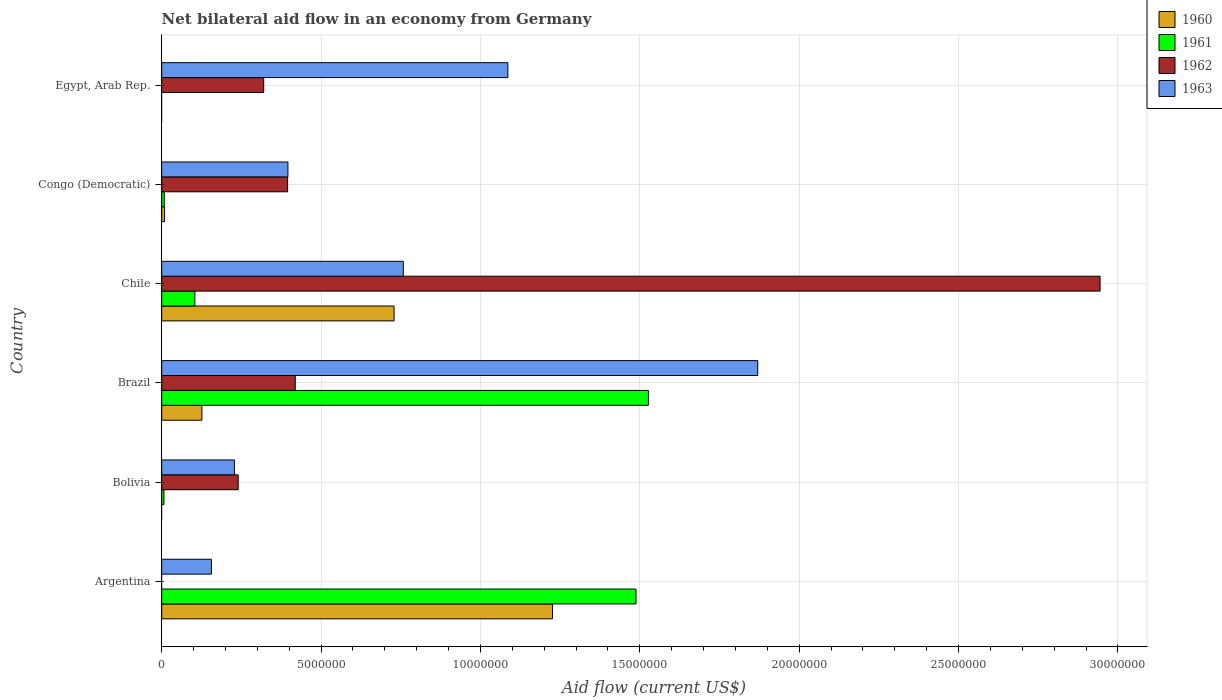How many different coloured bars are there?
Your answer should be very brief. 4. How many groups of bars are there?
Offer a very short reply. 6. Are the number of bars on each tick of the Y-axis equal?
Keep it short and to the point. No. How many bars are there on the 3rd tick from the top?
Give a very brief answer. 4. How many bars are there on the 2nd tick from the bottom?
Your answer should be compact. 3. What is the label of the 3rd group of bars from the top?
Ensure brevity in your answer.  Chile. What is the net bilateral aid flow in 1962 in Egypt, Arab Rep.?
Provide a short and direct response. 3.20e+06. Across all countries, what is the maximum net bilateral aid flow in 1963?
Provide a short and direct response. 1.87e+07. Across all countries, what is the minimum net bilateral aid flow in 1963?
Your response must be concise. 1.56e+06. What is the total net bilateral aid flow in 1963 in the graph?
Provide a short and direct response. 4.49e+07. What is the difference between the net bilateral aid flow in 1961 in Bolivia and that in Chile?
Provide a succinct answer. -9.70e+05. What is the difference between the net bilateral aid flow in 1960 in Congo (Democratic) and the net bilateral aid flow in 1961 in Chile?
Your response must be concise. -9.50e+05. What is the average net bilateral aid flow in 1960 per country?
Offer a terse response. 3.48e+06. What is the difference between the net bilateral aid flow in 1963 and net bilateral aid flow in 1960 in Argentina?
Offer a terse response. -1.07e+07. In how many countries, is the net bilateral aid flow in 1961 greater than 16000000 US$?
Make the answer very short. 0. What is the ratio of the net bilateral aid flow in 1961 in Argentina to that in Bolivia?
Make the answer very short. 212.57. What is the difference between the highest and the second highest net bilateral aid flow in 1961?
Offer a very short reply. 3.90e+05. What is the difference between the highest and the lowest net bilateral aid flow in 1960?
Your response must be concise. 1.23e+07. In how many countries, is the net bilateral aid flow in 1963 greater than the average net bilateral aid flow in 1963 taken over all countries?
Your response must be concise. 3. How many bars are there?
Ensure brevity in your answer.  20. Are all the bars in the graph horizontal?
Provide a short and direct response. Yes. How many countries are there in the graph?
Make the answer very short. 6. What is the difference between two consecutive major ticks on the X-axis?
Offer a terse response. 5.00e+06. Are the values on the major ticks of X-axis written in scientific E-notation?
Ensure brevity in your answer.  No. What is the title of the graph?
Provide a short and direct response. Net bilateral aid flow in an economy from Germany. Does "2013" appear as one of the legend labels in the graph?
Give a very brief answer. No. What is the label or title of the Y-axis?
Your answer should be very brief. Country. What is the Aid flow (current US$) in 1960 in Argentina?
Your answer should be compact. 1.23e+07. What is the Aid flow (current US$) of 1961 in Argentina?
Ensure brevity in your answer.  1.49e+07. What is the Aid flow (current US$) of 1963 in Argentina?
Your answer should be very brief. 1.56e+06. What is the Aid flow (current US$) of 1961 in Bolivia?
Keep it short and to the point. 7.00e+04. What is the Aid flow (current US$) of 1962 in Bolivia?
Provide a succinct answer. 2.40e+06. What is the Aid flow (current US$) of 1963 in Bolivia?
Your answer should be very brief. 2.28e+06. What is the Aid flow (current US$) in 1960 in Brazil?
Your answer should be very brief. 1.26e+06. What is the Aid flow (current US$) in 1961 in Brazil?
Your answer should be compact. 1.53e+07. What is the Aid flow (current US$) in 1962 in Brazil?
Your answer should be compact. 4.19e+06. What is the Aid flow (current US$) in 1963 in Brazil?
Ensure brevity in your answer.  1.87e+07. What is the Aid flow (current US$) of 1960 in Chile?
Offer a very short reply. 7.29e+06. What is the Aid flow (current US$) in 1961 in Chile?
Give a very brief answer. 1.04e+06. What is the Aid flow (current US$) of 1962 in Chile?
Offer a terse response. 2.94e+07. What is the Aid flow (current US$) of 1963 in Chile?
Give a very brief answer. 7.58e+06. What is the Aid flow (current US$) in 1960 in Congo (Democratic)?
Your answer should be very brief. 9.00e+04. What is the Aid flow (current US$) of 1961 in Congo (Democratic)?
Ensure brevity in your answer.  8.00e+04. What is the Aid flow (current US$) of 1962 in Congo (Democratic)?
Provide a succinct answer. 3.95e+06. What is the Aid flow (current US$) in 1963 in Congo (Democratic)?
Provide a succinct answer. 3.96e+06. What is the Aid flow (current US$) of 1960 in Egypt, Arab Rep.?
Your answer should be compact. 0. What is the Aid flow (current US$) in 1962 in Egypt, Arab Rep.?
Ensure brevity in your answer.  3.20e+06. What is the Aid flow (current US$) in 1963 in Egypt, Arab Rep.?
Provide a short and direct response. 1.09e+07. Across all countries, what is the maximum Aid flow (current US$) of 1960?
Your response must be concise. 1.23e+07. Across all countries, what is the maximum Aid flow (current US$) of 1961?
Ensure brevity in your answer.  1.53e+07. Across all countries, what is the maximum Aid flow (current US$) of 1962?
Your answer should be very brief. 2.94e+07. Across all countries, what is the maximum Aid flow (current US$) in 1963?
Give a very brief answer. 1.87e+07. Across all countries, what is the minimum Aid flow (current US$) in 1960?
Ensure brevity in your answer.  0. Across all countries, what is the minimum Aid flow (current US$) of 1962?
Ensure brevity in your answer.  0. Across all countries, what is the minimum Aid flow (current US$) in 1963?
Make the answer very short. 1.56e+06. What is the total Aid flow (current US$) of 1960 in the graph?
Your answer should be very brief. 2.09e+07. What is the total Aid flow (current US$) of 1961 in the graph?
Your answer should be compact. 3.13e+07. What is the total Aid flow (current US$) of 1962 in the graph?
Your answer should be compact. 4.32e+07. What is the total Aid flow (current US$) in 1963 in the graph?
Provide a short and direct response. 4.49e+07. What is the difference between the Aid flow (current US$) in 1961 in Argentina and that in Bolivia?
Make the answer very short. 1.48e+07. What is the difference between the Aid flow (current US$) of 1963 in Argentina and that in Bolivia?
Ensure brevity in your answer.  -7.20e+05. What is the difference between the Aid flow (current US$) in 1960 in Argentina and that in Brazil?
Your answer should be compact. 1.10e+07. What is the difference between the Aid flow (current US$) in 1961 in Argentina and that in Brazil?
Your answer should be very brief. -3.90e+05. What is the difference between the Aid flow (current US$) of 1963 in Argentina and that in Brazil?
Offer a very short reply. -1.71e+07. What is the difference between the Aid flow (current US$) in 1960 in Argentina and that in Chile?
Keep it short and to the point. 4.97e+06. What is the difference between the Aid flow (current US$) of 1961 in Argentina and that in Chile?
Offer a terse response. 1.38e+07. What is the difference between the Aid flow (current US$) of 1963 in Argentina and that in Chile?
Your answer should be very brief. -6.02e+06. What is the difference between the Aid flow (current US$) in 1960 in Argentina and that in Congo (Democratic)?
Your answer should be very brief. 1.22e+07. What is the difference between the Aid flow (current US$) in 1961 in Argentina and that in Congo (Democratic)?
Make the answer very short. 1.48e+07. What is the difference between the Aid flow (current US$) of 1963 in Argentina and that in Congo (Democratic)?
Ensure brevity in your answer.  -2.40e+06. What is the difference between the Aid flow (current US$) in 1963 in Argentina and that in Egypt, Arab Rep.?
Ensure brevity in your answer.  -9.30e+06. What is the difference between the Aid flow (current US$) of 1961 in Bolivia and that in Brazil?
Your answer should be very brief. -1.52e+07. What is the difference between the Aid flow (current US$) of 1962 in Bolivia and that in Brazil?
Your answer should be very brief. -1.79e+06. What is the difference between the Aid flow (current US$) in 1963 in Bolivia and that in Brazil?
Ensure brevity in your answer.  -1.64e+07. What is the difference between the Aid flow (current US$) in 1961 in Bolivia and that in Chile?
Make the answer very short. -9.70e+05. What is the difference between the Aid flow (current US$) of 1962 in Bolivia and that in Chile?
Your response must be concise. -2.70e+07. What is the difference between the Aid flow (current US$) in 1963 in Bolivia and that in Chile?
Keep it short and to the point. -5.30e+06. What is the difference between the Aid flow (current US$) of 1962 in Bolivia and that in Congo (Democratic)?
Your answer should be very brief. -1.55e+06. What is the difference between the Aid flow (current US$) of 1963 in Bolivia and that in Congo (Democratic)?
Offer a terse response. -1.68e+06. What is the difference between the Aid flow (current US$) of 1962 in Bolivia and that in Egypt, Arab Rep.?
Ensure brevity in your answer.  -8.00e+05. What is the difference between the Aid flow (current US$) of 1963 in Bolivia and that in Egypt, Arab Rep.?
Offer a very short reply. -8.58e+06. What is the difference between the Aid flow (current US$) in 1960 in Brazil and that in Chile?
Ensure brevity in your answer.  -6.03e+06. What is the difference between the Aid flow (current US$) of 1961 in Brazil and that in Chile?
Ensure brevity in your answer.  1.42e+07. What is the difference between the Aid flow (current US$) of 1962 in Brazil and that in Chile?
Give a very brief answer. -2.52e+07. What is the difference between the Aid flow (current US$) of 1963 in Brazil and that in Chile?
Your response must be concise. 1.11e+07. What is the difference between the Aid flow (current US$) of 1960 in Brazil and that in Congo (Democratic)?
Give a very brief answer. 1.17e+06. What is the difference between the Aid flow (current US$) in 1961 in Brazil and that in Congo (Democratic)?
Keep it short and to the point. 1.52e+07. What is the difference between the Aid flow (current US$) of 1962 in Brazil and that in Congo (Democratic)?
Offer a terse response. 2.40e+05. What is the difference between the Aid flow (current US$) of 1963 in Brazil and that in Congo (Democratic)?
Make the answer very short. 1.47e+07. What is the difference between the Aid flow (current US$) in 1962 in Brazil and that in Egypt, Arab Rep.?
Provide a succinct answer. 9.90e+05. What is the difference between the Aid flow (current US$) of 1963 in Brazil and that in Egypt, Arab Rep.?
Keep it short and to the point. 7.84e+06. What is the difference between the Aid flow (current US$) of 1960 in Chile and that in Congo (Democratic)?
Your response must be concise. 7.20e+06. What is the difference between the Aid flow (current US$) in 1961 in Chile and that in Congo (Democratic)?
Your response must be concise. 9.60e+05. What is the difference between the Aid flow (current US$) in 1962 in Chile and that in Congo (Democratic)?
Your answer should be very brief. 2.55e+07. What is the difference between the Aid flow (current US$) of 1963 in Chile and that in Congo (Democratic)?
Make the answer very short. 3.62e+06. What is the difference between the Aid flow (current US$) in 1962 in Chile and that in Egypt, Arab Rep.?
Offer a very short reply. 2.62e+07. What is the difference between the Aid flow (current US$) in 1963 in Chile and that in Egypt, Arab Rep.?
Offer a terse response. -3.28e+06. What is the difference between the Aid flow (current US$) of 1962 in Congo (Democratic) and that in Egypt, Arab Rep.?
Your response must be concise. 7.50e+05. What is the difference between the Aid flow (current US$) in 1963 in Congo (Democratic) and that in Egypt, Arab Rep.?
Provide a succinct answer. -6.90e+06. What is the difference between the Aid flow (current US$) in 1960 in Argentina and the Aid flow (current US$) in 1961 in Bolivia?
Give a very brief answer. 1.22e+07. What is the difference between the Aid flow (current US$) of 1960 in Argentina and the Aid flow (current US$) of 1962 in Bolivia?
Your answer should be very brief. 9.86e+06. What is the difference between the Aid flow (current US$) in 1960 in Argentina and the Aid flow (current US$) in 1963 in Bolivia?
Ensure brevity in your answer.  9.98e+06. What is the difference between the Aid flow (current US$) in 1961 in Argentina and the Aid flow (current US$) in 1962 in Bolivia?
Give a very brief answer. 1.25e+07. What is the difference between the Aid flow (current US$) of 1961 in Argentina and the Aid flow (current US$) of 1963 in Bolivia?
Make the answer very short. 1.26e+07. What is the difference between the Aid flow (current US$) in 1960 in Argentina and the Aid flow (current US$) in 1961 in Brazil?
Provide a short and direct response. -3.01e+06. What is the difference between the Aid flow (current US$) of 1960 in Argentina and the Aid flow (current US$) of 1962 in Brazil?
Ensure brevity in your answer.  8.07e+06. What is the difference between the Aid flow (current US$) of 1960 in Argentina and the Aid flow (current US$) of 1963 in Brazil?
Ensure brevity in your answer.  -6.44e+06. What is the difference between the Aid flow (current US$) of 1961 in Argentina and the Aid flow (current US$) of 1962 in Brazil?
Your answer should be compact. 1.07e+07. What is the difference between the Aid flow (current US$) of 1961 in Argentina and the Aid flow (current US$) of 1963 in Brazil?
Your answer should be compact. -3.82e+06. What is the difference between the Aid flow (current US$) in 1960 in Argentina and the Aid flow (current US$) in 1961 in Chile?
Your answer should be compact. 1.12e+07. What is the difference between the Aid flow (current US$) in 1960 in Argentina and the Aid flow (current US$) in 1962 in Chile?
Provide a short and direct response. -1.72e+07. What is the difference between the Aid flow (current US$) of 1960 in Argentina and the Aid flow (current US$) of 1963 in Chile?
Your answer should be very brief. 4.68e+06. What is the difference between the Aid flow (current US$) of 1961 in Argentina and the Aid flow (current US$) of 1962 in Chile?
Your response must be concise. -1.46e+07. What is the difference between the Aid flow (current US$) in 1961 in Argentina and the Aid flow (current US$) in 1963 in Chile?
Your answer should be very brief. 7.30e+06. What is the difference between the Aid flow (current US$) of 1960 in Argentina and the Aid flow (current US$) of 1961 in Congo (Democratic)?
Offer a terse response. 1.22e+07. What is the difference between the Aid flow (current US$) of 1960 in Argentina and the Aid flow (current US$) of 1962 in Congo (Democratic)?
Your response must be concise. 8.31e+06. What is the difference between the Aid flow (current US$) in 1960 in Argentina and the Aid flow (current US$) in 1963 in Congo (Democratic)?
Your answer should be compact. 8.30e+06. What is the difference between the Aid flow (current US$) of 1961 in Argentina and the Aid flow (current US$) of 1962 in Congo (Democratic)?
Provide a short and direct response. 1.09e+07. What is the difference between the Aid flow (current US$) in 1961 in Argentina and the Aid flow (current US$) in 1963 in Congo (Democratic)?
Offer a terse response. 1.09e+07. What is the difference between the Aid flow (current US$) in 1960 in Argentina and the Aid flow (current US$) in 1962 in Egypt, Arab Rep.?
Provide a succinct answer. 9.06e+06. What is the difference between the Aid flow (current US$) of 1960 in Argentina and the Aid flow (current US$) of 1963 in Egypt, Arab Rep.?
Your response must be concise. 1.40e+06. What is the difference between the Aid flow (current US$) in 1961 in Argentina and the Aid flow (current US$) in 1962 in Egypt, Arab Rep.?
Make the answer very short. 1.17e+07. What is the difference between the Aid flow (current US$) in 1961 in Argentina and the Aid flow (current US$) in 1963 in Egypt, Arab Rep.?
Make the answer very short. 4.02e+06. What is the difference between the Aid flow (current US$) in 1961 in Bolivia and the Aid flow (current US$) in 1962 in Brazil?
Your response must be concise. -4.12e+06. What is the difference between the Aid flow (current US$) of 1961 in Bolivia and the Aid flow (current US$) of 1963 in Brazil?
Provide a short and direct response. -1.86e+07. What is the difference between the Aid flow (current US$) of 1962 in Bolivia and the Aid flow (current US$) of 1963 in Brazil?
Your answer should be compact. -1.63e+07. What is the difference between the Aid flow (current US$) in 1961 in Bolivia and the Aid flow (current US$) in 1962 in Chile?
Provide a short and direct response. -2.94e+07. What is the difference between the Aid flow (current US$) of 1961 in Bolivia and the Aid flow (current US$) of 1963 in Chile?
Your answer should be very brief. -7.51e+06. What is the difference between the Aid flow (current US$) in 1962 in Bolivia and the Aid flow (current US$) in 1963 in Chile?
Provide a short and direct response. -5.18e+06. What is the difference between the Aid flow (current US$) in 1961 in Bolivia and the Aid flow (current US$) in 1962 in Congo (Democratic)?
Offer a terse response. -3.88e+06. What is the difference between the Aid flow (current US$) of 1961 in Bolivia and the Aid flow (current US$) of 1963 in Congo (Democratic)?
Your answer should be compact. -3.89e+06. What is the difference between the Aid flow (current US$) of 1962 in Bolivia and the Aid flow (current US$) of 1963 in Congo (Democratic)?
Offer a terse response. -1.56e+06. What is the difference between the Aid flow (current US$) in 1961 in Bolivia and the Aid flow (current US$) in 1962 in Egypt, Arab Rep.?
Provide a succinct answer. -3.13e+06. What is the difference between the Aid flow (current US$) of 1961 in Bolivia and the Aid flow (current US$) of 1963 in Egypt, Arab Rep.?
Make the answer very short. -1.08e+07. What is the difference between the Aid flow (current US$) of 1962 in Bolivia and the Aid flow (current US$) of 1963 in Egypt, Arab Rep.?
Offer a terse response. -8.46e+06. What is the difference between the Aid flow (current US$) of 1960 in Brazil and the Aid flow (current US$) of 1961 in Chile?
Keep it short and to the point. 2.20e+05. What is the difference between the Aid flow (current US$) of 1960 in Brazil and the Aid flow (current US$) of 1962 in Chile?
Your answer should be compact. -2.82e+07. What is the difference between the Aid flow (current US$) of 1960 in Brazil and the Aid flow (current US$) of 1963 in Chile?
Provide a short and direct response. -6.32e+06. What is the difference between the Aid flow (current US$) of 1961 in Brazil and the Aid flow (current US$) of 1962 in Chile?
Provide a short and direct response. -1.42e+07. What is the difference between the Aid flow (current US$) in 1961 in Brazil and the Aid flow (current US$) in 1963 in Chile?
Ensure brevity in your answer.  7.69e+06. What is the difference between the Aid flow (current US$) of 1962 in Brazil and the Aid flow (current US$) of 1963 in Chile?
Your response must be concise. -3.39e+06. What is the difference between the Aid flow (current US$) of 1960 in Brazil and the Aid flow (current US$) of 1961 in Congo (Democratic)?
Provide a short and direct response. 1.18e+06. What is the difference between the Aid flow (current US$) in 1960 in Brazil and the Aid flow (current US$) in 1962 in Congo (Democratic)?
Your answer should be very brief. -2.69e+06. What is the difference between the Aid flow (current US$) in 1960 in Brazil and the Aid flow (current US$) in 1963 in Congo (Democratic)?
Give a very brief answer. -2.70e+06. What is the difference between the Aid flow (current US$) of 1961 in Brazil and the Aid flow (current US$) of 1962 in Congo (Democratic)?
Keep it short and to the point. 1.13e+07. What is the difference between the Aid flow (current US$) of 1961 in Brazil and the Aid flow (current US$) of 1963 in Congo (Democratic)?
Your response must be concise. 1.13e+07. What is the difference between the Aid flow (current US$) of 1962 in Brazil and the Aid flow (current US$) of 1963 in Congo (Democratic)?
Provide a short and direct response. 2.30e+05. What is the difference between the Aid flow (current US$) of 1960 in Brazil and the Aid flow (current US$) of 1962 in Egypt, Arab Rep.?
Keep it short and to the point. -1.94e+06. What is the difference between the Aid flow (current US$) in 1960 in Brazil and the Aid flow (current US$) in 1963 in Egypt, Arab Rep.?
Offer a very short reply. -9.60e+06. What is the difference between the Aid flow (current US$) of 1961 in Brazil and the Aid flow (current US$) of 1962 in Egypt, Arab Rep.?
Ensure brevity in your answer.  1.21e+07. What is the difference between the Aid flow (current US$) in 1961 in Brazil and the Aid flow (current US$) in 1963 in Egypt, Arab Rep.?
Your answer should be very brief. 4.41e+06. What is the difference between the Aid flow (current US$) of 1962 in Brazil and the Aid flow (current US$) of 1963 in Egypt, Arab Rep.?
Your response must be concise. -6.67e+06. What is the difference between the Aid flow (current US$) of 1960 in Chile and the Aid flow (current US$) of 1961 in Congo (Democratic)?
Offer a terse response. 7.21e+06. What is the difference between the Aid flow (current US$) in 1960 in Chile and the Aid flow (current US$) in 1962 in Congo (Democratic)?
Give a very brief answer. 3.34e+06. What is the difference between the Aid flow (current US$) of 1960 in Chile and the Aid flow (current US$) of 1963 in Congo (Democratic)?
Your answer should be compact. 3.33e+06. What is the difference between the Aid flow (current US$) of 1961 in Chile and the Aid flow (current US$) of 1962 in Congo (Democratic)?
Provide a short and direct response. -2.91e+06. What is the difference between the Aid flow (current US$) of 1961 in Chile and the Aid flow (current US$) of 1963 in Congo (Democratic)?
Your response must be concise. -2.92e+06. What is the difference between the Aid flow (current US$) in 1962 in Chile and the Aid flow (current US$) in 1963 in Congo (Democratic)?
Your response must be concise. 2.55e+07. What is the difference between the Aid flow (current US$) in 1960 in Chile and the Aid flow (current US$) in 1962 in Egypt, Arab Rep.?
Keep it short and to the point. 4.09e+06. What is the difference between the Aid flow (current US$) of 1960 in Chile and the Aid flow (current US$) of 1963 in Egypt, Arab Rep.?
Provide a short and direct response. -3.57e+06. What is the difference between the Aid flow (current US$) in 1961 in Chile and the Aid flow (current US$) in 1962 in Egypt, Arab Rep.?
Ensure brevity in your answer.  -2.16e+06. What is the difference between the Aid flow (current US$) in 1961 in Chile and the Aid flow (current US$) in 1963 in Egypt, Arab Rep.?
Your response must be concise. -9.82e+06. What is the difference between the Aid flow (current US$) in 1962 in Chile and the Aid flow (current US$) in 1963 in Egypt, Arab Rep.?
Offer a very short reply. 1.86e+07. What is the difference between the Aid flow (current US$) of 1960 in Congo (Democratic) and the Aid flow (current US$) of 1962 in Egypt, Arab Rep.?
Offer a very short reply. -3.11e+06. What is the difference between the Aid flow (current US$) in 1960 in Congo (Democratic) and the Aid flow (current US$) in 1963 in Egypt, Arab Rep.?
Ensure brevity in your answer.  -1.08e+07. What is the difference between the Aid flow (current US$) of 1961 in Congo (Democratic) and the Aid flow (current US$) of 1962 in Egypt, Arab Rep.?
Give a very brief answer. -3.12e+06. What is the difference between the Aid flow (current US$) in 1961 in Congo (Democratic) and the Aid flow (current US$) in 1963 in Egypt, Arab Rep.?
Ensure brevity in your answer.  -1.08e+07. What is the difference between the Aid flow (current US$) of 1962 in Congo (Democratic) and the Aid flow (current US$) of 1963 in Egypt, Arab Rep.?
Ensure brevity in your answer.  -6.91e+06. What is the average Aid flow (current US$) of 1960 per country?
Your answer should be compact. 3.48e+06. What is the average Aid flow (current US$) of 1961 per country?
Make the answer very short. 5.22e+06. What is the average Aid flow (current US$) in 1962 per country?
Your response must be concise. 7.20e+06. What is the average Aid flow (current US$) of 1963 per country?
Your response must be concise. 7.49e+06. What is the difference between the Aid flow (current US$) of 1960 and Aid flow (current US$) of 1961 in Argentina?
Provide a succinct answer. -2.62e+06. What is the difference between the Aid flow (current US$) in 1960 and Aid flow (current US$) in 1963 in Argentina?
Give a very brief answer. 1.07e+07. What is the difference between the Aid flow (current US$) of 1961 and Aid flow (current US$) of 1963 in Argentina?
Your answer should be very brief. 1.33e+07. What is the difference between the Aid flow (current US$) of 1961 and Aid flow (current US$) of 1962 in Bolivia?
Offer a very short reply. -2.33e+06. What is the difference between the Aid flow (current US$) in 1961 and Aid flow (current US$) in 1963 in Bolivia?
Offer a very short reply. -2.21e+06. What is the difference between the Aid flow (current US$) in 1960 and Aid flow (current US$) in 1961 in Brazil?
Offer a terse response. -1.40e+07. What is the difference between the Aid flow (current US$) of 1960 and Aid flow (current US$) of 1962 in Brazil?
Keep it short and to the point. -2.93e+06. What is the difference between the Aid flow (current US$) of 1960 and Aid flow (current US$) of 1963 in Brazil?
Offer a terse response. -1.74e+07. What is the difference between the Aid flow (current US$) in 1961 and Aid flow (current US$) in 1962 in Brazil?
Your response must be concise. 1.11e+07. What is the difference between the Aid flow (current US$) of 1961 and Aid flow (current US$) of 1963 in Brazil?
Your answer should be very brief. -3.43e+06. What is the difference between the Aid flow (current US$) of 1962 and Aid flow (current US$) of 1963 in Brazil?
Your answer should be compact. -1.45e+07. What is the difference between the Aid flow (current US$) of 1960 and Aid flow (current US$) of 1961 in Chile?
Provide a short and direct response. 6.25e+06. What is the difference between the Aid flow (current US$) in 1960 and Aid flow (current US$) in 1962 in Chile?
Your answer should be compact. -2.22e+07. What is the difference between the Aid flow (current US$) in 1961 and Aid flow (current US$) in 1962 in Chile?
Your answer should be very brief. -2.84e+07. What is the difference between the Aid flow (current US$) in 1961 and Aid flow (current US$) in 1963 in Chile?
Your answer should be compact. -6.54e+06. What is the difference between the Aid flow (current US$) in 1962 and Aid flow (current US$) in 1963 in Chile?
Make the answer very short. 2.19e+07. What is the difference between the Aid flow (current US$) in 1960 and Aid flow (current US$) in 1961 in Congo (Democratic)?
Provide a short and direct response. 10000. What is the difference between the Aid flow (current US$) of 1960 and Aid flow (current US$) of 1962 in Congo (Democratic)?
Provide a short and direct response. -3.86e+06. What is the difference between the Aid flow (current US$) in 1960 and Aid flow (current US$) in 1963 in Congo (Democratic)?
Your response must be concise. -3.87e+06. What is the difference between the Aid flow (current US$) of 1961 and Aid flow (current US$) of 1962 in Congo (Democratic)?
Keep it short and to the point. -3.87e+06. What is the difference between the Aid flow (current US$) of 1961 and Aid flow (current US$) of 1963 in Congo (Democratic)?
Offer a very short reply. -3.88e+06. What is the difference between the Aid flow (current US$) in 1962 and Aid flow (current US$) in 1963 in Congo (Democratic)?
Keep it short and to the point. -10000. What is the difference between the Aid flow (current US$) in 1962 and Aid flow (current US$) in 1963 in Egypt, Arab Rep.?
Give a very brief answer. -7.66e+06. What is the ratio of the Aid flow (current US$) in 1961 in Argentina to that in Bolivia?
Provide a short and direct response. 212.57. What is the ratio of the Aid flow (current US$) of 1963 in Argentina to that in Bolivia?
Provide a short and direct response. 0.68. What is the ratio of the Aid flow (current US$) of 1960 in Argentina to that in Brazil?
Offer a very short reply. 9.73. What is the ratio of the Aid flow (current US$) in 1961 in Argentina to that in Brazil?
Provide a succinct answer. 0.97. What is the ratio of the Aid flow (current US$) in 1963 in Argentina to that in Brazil?
Your answer should be very brief. 0.08. What is the ratio of the Aid flow (current US$) in 1960 in Argentina to that in Chile?
Offer a very short reply. 1.68. What is the ratio of the Aid flow (current US$) in 1961 in Argentina to that in Chile?
Ensure brevity in your answer.  14.31. What is the ratio of the Aid flow (current US$) of 1963 in Argentina to that in Chile?
Give a very brief answer. 0.21. What is the ratio of the Aid flow (current US$) of 1960 in Argentina to that in Congo (Democratic)?
Keep it short and to the point. 136.22. What is the ratio of the Aid flow (current US$) of 1961 in Argentina to that in Congo (Democratic)?
Offer a very short reply. 186. What is the ratio of the Aid flow (current US$) in 1963 in Argentina to that in Congo (Democratic)?
Your answer should be compact. 0.39. What is the ratio of the Aid flow (current US$) of 1963 in Argentina to that in Egypt, Arab Rep.?
Provide a succinct answer. 0.14. What is the ratio of the Aid flow (current US$) of 1961 in Bolivia to that in Brazil?
Your answer should be compact. 0. What is the ratio of the Aid flow (current US$) in 1962 in Bolivia to that in Brazil?
Make the answer very short. 0.57. What is the ratio of the Aid flow (current US$) of 1963 in Bolivia to that in Brazil?
Provide a short and direct response. 0.12. What is the ratio of the Aid flow (current US$) of 1961 in Bolivia to that in Chile?
Your answer should be compact. 0.07. What is the ratio of the Aid flow (current US$) of 1962 in Bolivia to that in Chile?
Provide a short and direct response. 0.08. What is the ratio of the Aid flow (current US$) in 1963 in Bolivia to that in Chile?
Provide a succinct answer. 0.3. What is the ratio of the Aid flow (current US$) of 1961 in Bolivia to that in Congo (Democratic)?
Give a very brief answer. 0.88. What is the ratio of the Aid flow (current US$) in 1962 in Bolivia to that in Congo (Democratic)?
Ensure brevity in your answer.  0.61. What is the ratio of the Aid flow (current US$) in 1963 in Bolivia to that in Congo (Democratic)?
Offer a terse response. 0.58. What is the ratio of the Aid flow (current US$) in 1962 in Bolivia to that in Egypt, Arab Rep.?
Offer a terse response. 0.75. What is the ratio of the Aid flow (current US$) of 1963 in Bolivia to that in Egypt, Arab Rep.?
Give a very brief answer. 0.21. What is the ratio of the Aid flow (current US$) in 1960 in Brazil to that in Chile?
Make the answer very short. 0.17. What is the ratio of the Aid flow (current US$) in 1961 in Brazil to that in Chile?
Keep it short and to the point. 14.68. What is the ratio of the Aid flow (current US$) of 1962 in Brazil to that in Chile?
Provide a short and direct response. 0.14. What is the ratio of the Aid flow (current US$) in 1963 in Brazil to that in Chile?
Ensure brevity in your answer.  2.47. What is the ratio of the Aid flow (current US$) of 1960 in Brazil to that in Congo (Democratic)?
Make the answer very short. 14. What is the ratio of the Aid flow (current US$) of 1961 in Brazil to that in Congo (Democratic)?
Ensure brevity in your answer.  190.88. What is the ratio of the Aid flow (current US$) of 1962 in Brazil to that in Congo (Democratic)?
Provide a succinct answer. 1.06. What is the ratio of the Aid flow (current US$) in 1963 in Brazil to that in Congo (Democratic)?
Your answer should be compact. 4.72. What is the ratio of the Aid flow (current US$) of 1962 in Brazil to that in Egypt, Arab Rep.?
Keep it short and to the point. 1.31. What is the ratio of the Aid flow (current US$) of 1963 in Brazil to that in Egypt, Arab Rep.?
Provide a short and direct response. 1.72. What is the ratio of the Aid flow (current US$) in 1962 in Chile to that in Congo (Democratic)?
Your response must be concise. 7.45. What is the ratio of the Aid flow (current US$) in 1963 in Chile to that in Congo (Democratic)?
Give a very brief answer. 1.91. What is the ratio of the Aid flow (current US$) in 1963 in Chile to that in Egypt, Arab Rep.?
Make the answer very short. 0.7. What is the ratio of the Aid flow (current US$) of 1962 in Congo (Democratic) to that in Egypt, Arab Rep.?
Your answer should be compact. 1.23. What is the ratio of the Aid flow (current US$) in 1963 in Congo (Democratic) to that in Egypt, Arab Rep.?
Ensure brevity in your answer.  0.36. What is the difference between the highest and the second highest Aid flow (current US$) in 1960?
Make the answer very short. 4.97e+06. What is the difference between the highest and the second highest Aid flow (current US$) in 1962?
Give a very brief answer. 2.52e+07. What is the difference between the highest and the second highest Aid flow (current US$) in 1963?
Make the answer very short. 7.84e+06. What is the difference between the highest and the lowest Aid flow (current US$) of 1960?
Keep it short and to the point. 1.23e+07. What is the difference between the highest and the lowest Aid flow (current US$) in 1961?
Your answer should be very brief. 1.53e+07. What is the difference between the highest and the lowest Aid flow (current US$) in 1962?
Offer a terse response. 2.94e+07. What is the difference between the highest and the lowest Aid flow (current US$) of 1963?
Your answer should be compact. 1.71e+07. 